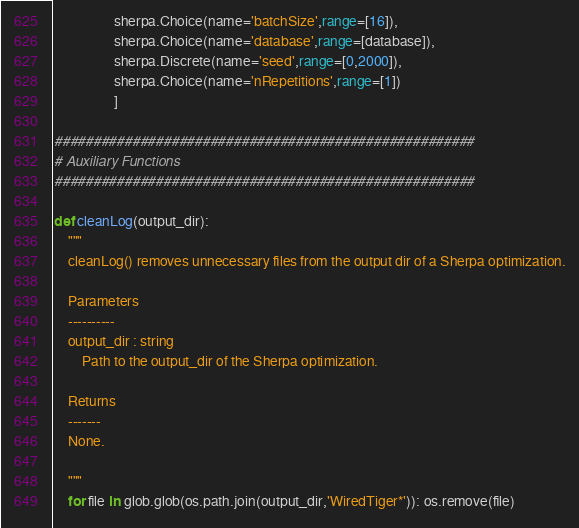Convert code to text. <code><loc_0><loc_0><loc_500><loc_500><_Python_>                 sherpa.Choice(name='batchSize',range=[16]),
                 sherpa.Choice(name='database',range=[database]),
                 sherpa.Discrete(name='seed',range=[0,2000]),
                 sherpa.Choice(name='nRepetitions',range=[1])
                 ]

######################################################
# Auxiliary Functions
######################################################

def cleanLog(output_dir):
    """
    cleanLog() removes unnecessary files from the output dir of a Sherpa optimization.

    Parameters
    ----------
    output_dir : string
        Path to the output_dir of the Sherpa optimization.

    Returns
    -------
    None.

    """
    for file in glob.glob(os.path.join(output_dir,'WiredTiger*')): os.remove(file)</code> 